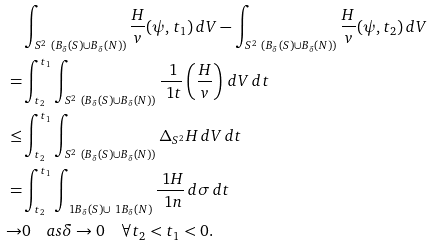Convert formula to latex. <formula><loc_0><loc_0><loc_500><loc_500>& \int _ { S ^ { 2 } \ ( B _ { \delta } ( S ) \cup B _ { \delta } ( N ) ) } \frac { H } { v } ( \psi , t _ { 1 } ) \, d V - \int _ { S ^ { 2 } \ ( B _ { \delta } ( S ) \cup B _ { \delta } ( N ) ) } \frac { H } { v } ( \psi , t _ { 2 } ) \, d V \\ = & \int _ { t _ { 2 } } ^ { t _ { 1 } } \int _ { S ^ { 2 } \ ( B _ { \delta } ( S ) \cup B _ { \delta } ( N ) ) } \frac { \ 1 } { \ 1 t } \left ( \frac { H } { v } \right ) \, d V \, d t \\ \leq & \int _ { t _ { 2 } } ^ { t _ { 1 } } \int _ { S ^ { 2 } \ ( B _ { \delta } ( S ) \cup B _ { \delta } ( N ) ) } \Delta _ { S ^ { 2 } } H \, d V \, d t \\ = & \int _ { t _ { 2 } } ^ { t _ { 1 } } \int _ { \ 1 B _ { \delta } ( S ) \cup \ 1 B _ { \delta } ( N ) } \frac { \ 1 H } { \ 1 n } \, d \sigma \, d t \\ \to & 0 \quad a s \delta \to 0 \quad \forall t _ { 2 } < t _ { 1 } < 0 .</formula> 